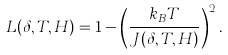<formula> <loc_0><loc_0><loc_500><loc_500>L ( \delta , T , H ) = 1 - \left ( \frac { k _ { B } T } { J ( \delta , T , H ) } \right ) ^ { 2 } .</formula> 